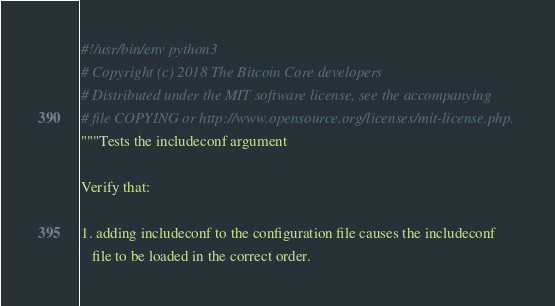Convert code to text. <code><loc_0><loc_0><loc_500><loc_500><_Python_>#!/usr/bin/env python3
# Copyright (c) 2018 The Bitcoin Core developers
# Distributed under the MIT software license, see the accompanying
# file COPYING or http://www.opensource.org/licenses/mit-license.php.
"""Tests the includeconf argument

Verify that:

1. adding includeconf to the configuration file causes the includeconf
   file to be loaded in the correct order.</code> 